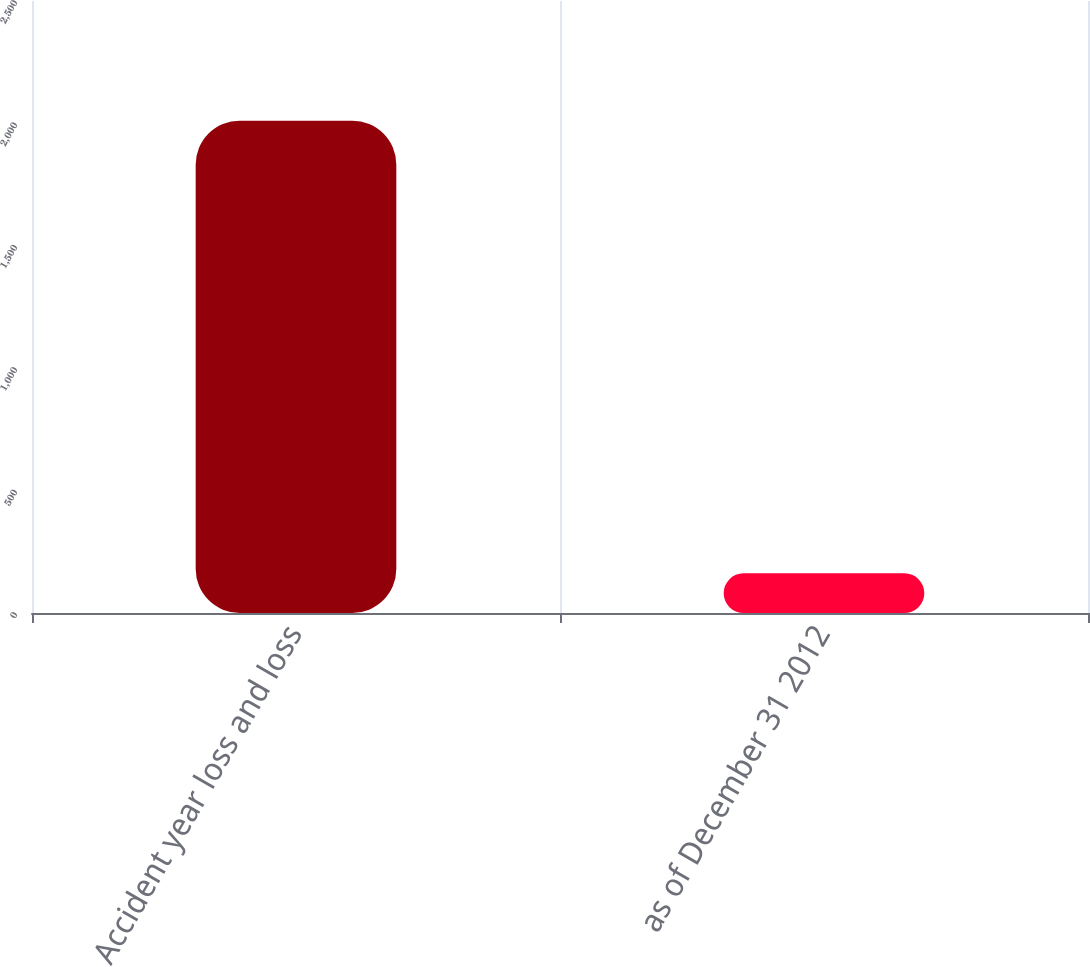Convert chart to OTSL. <chart><loc_0><loc_0><loc_500><loc_500><bar_chart><fcel>Accident year loss and loss<fcel>as of December 31 2012<nl><fcel>2011<fcel>162<nl></chart> 